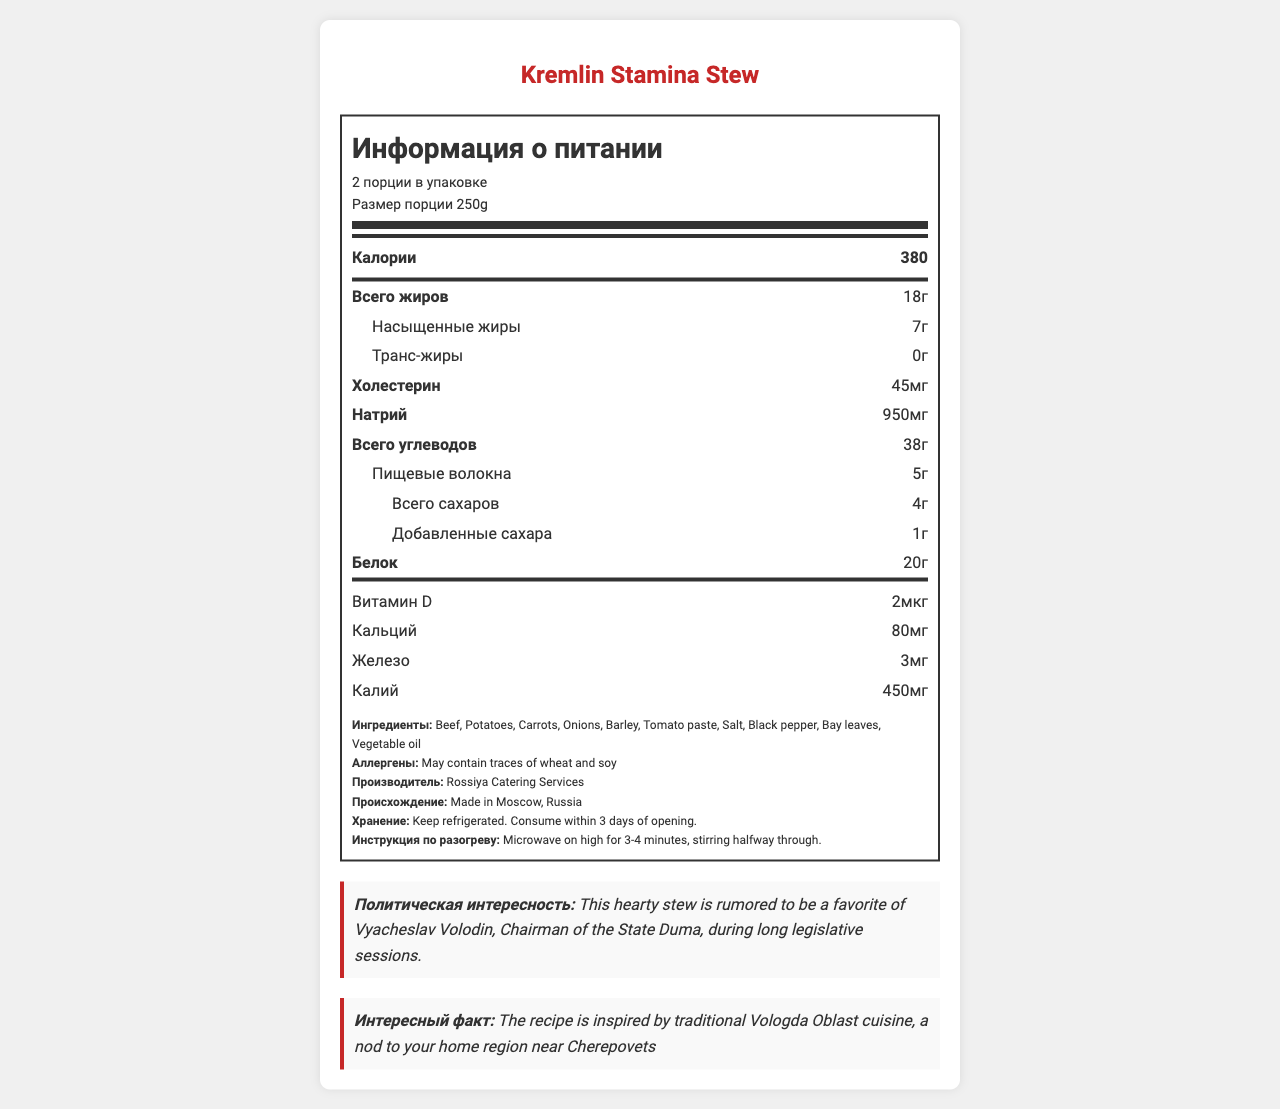How many calories are in one serving of Kremlin Stamina Stew? The document states that there are 380 calories in a serving size of 250g.
Answer: 380 calories What is the main ingredient in the Kremlin Stamina Stew? The first ingredient listed is "Beef," indicating it is the main ingredient.
Answer: Beef How much sodium does one serving contain? The nutrition label indicates that one serving contains 950 mg of sodium.
Answer: 950 mg What quantity of dietary fiber is in a single serving? The nutrition label shows that there are 5 grams of dietary fiber per serving.
Answer: 5g What is the recommended method for heating the stew? The document specifies the heating instructions as microwaving on high for 3-4 minutes while stirring halfway through.
Answer: Microwave on high for 3-4 minutes, stirring halfway through Which of the following vitamins is included in the Kremlin Stamina Stew? A. Vitamin C B. Vitamin D C. Vitamin B12 D. Vitamin K The nutrition label lists Vitamin D as being present in the stew, but not vitamins C, B12, or K.
Answer: B. Vitamin D How many servings are there per container? A. 1 B. 2 C. 3 D. 4 The document states that the product has 2 servings per container.
Answer: B. 2 Does this stew contain any trans fat? The nutrition label shows that there are 0 grams of trans fat per serving.
Answer: No Is this product high in protein? The document claims that it is "High in protein to support mental acuity during extended debates" and lists 20g of protein per serving.
Answer: Yes Summarize the nutritional information and other key features of the Kremlin Stamina Stew. The summary encapsulates the calorie count and breakdown of nutrients, highlights the main ingredients and manufacturer, and includes the interesting political trivia and regional inspiration.
Answer: The Kremlin Stamina Stew provides 380 calories per 250g serving and contains 18g total fat, 7g saturated fat, 0g trans fat, 45mg cholesterol, 950mg sodium, 38g total carbohydrates, 5g dietary fiber, 4g total sugars (with 1g added sugars), and 20g protein. It also contains Vitamin D (2µg), Calcium (80mg), Iron (3mg), and Potassium (450mg). The main ingredients are beef, potatoes, carrots, onions, barley, and tomato paste. The stew is produced by Rossiya Catering Services in Moscow and is rumored to be favored by Vyacheslav Volodin, Chairman of the State Duma, during long legislative sessions. It is also inspired by traditional Vologda Oblast cuisine. Does the document mention if the stew contains Vitamin A? The document does not list Vitamin A among the provided nutritional information.
Answer: No What is the humorous political trivia mentioned about the Kremlin Stamina Stew? The document includes a note that the stew is rumored to be Vyacheslav Volodin's favorite during long legislative sessions.
Answer: It's rumored to be a favorite of Vyacheslav Volodin, Chairman of the State Duma, during long legislative sessions. Can the stew be consumed immediately after purchase? The document advises keeping it refrigerated and consuming it within 3 days of opening, implying that some preparation or storage is required before consumption.
Answer: No 